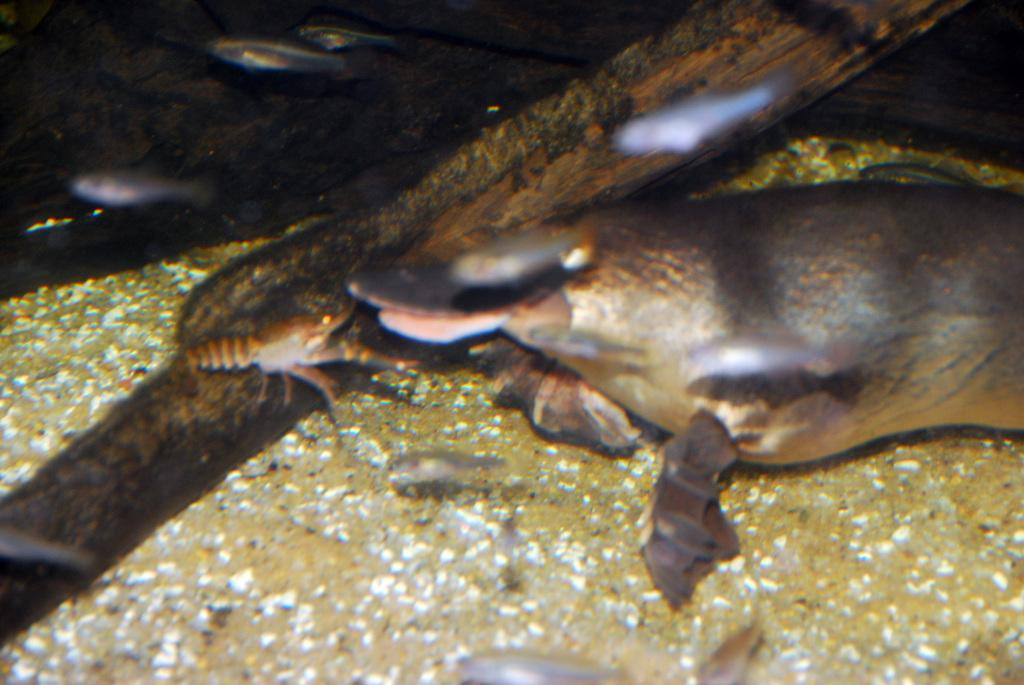What type of animals can be seen in the image? There are fishes and other water animals in the image. What is the primary element in which the animals are situated? The animals are situated in water, which is visible in the image. What can be found at the bottom of the image? There are stones at the bottom of the image. What type of food are the brothers eating in the image? There are no brothers or food present in the image; it features fishes and other water animals in water with stones at the bottom. 